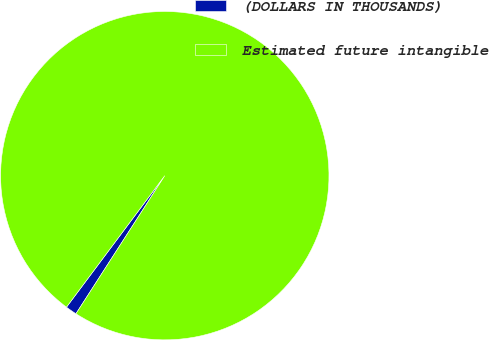Convert chart. <chart><loc_0><loc_0><loc_500><loc_500><pie_chart><fcel>(DOLLARS IN THOUSANDS)<fcel>Estimated future intangible<nl><fcel>1.12%<fcel>98.88%<nl></chart> 